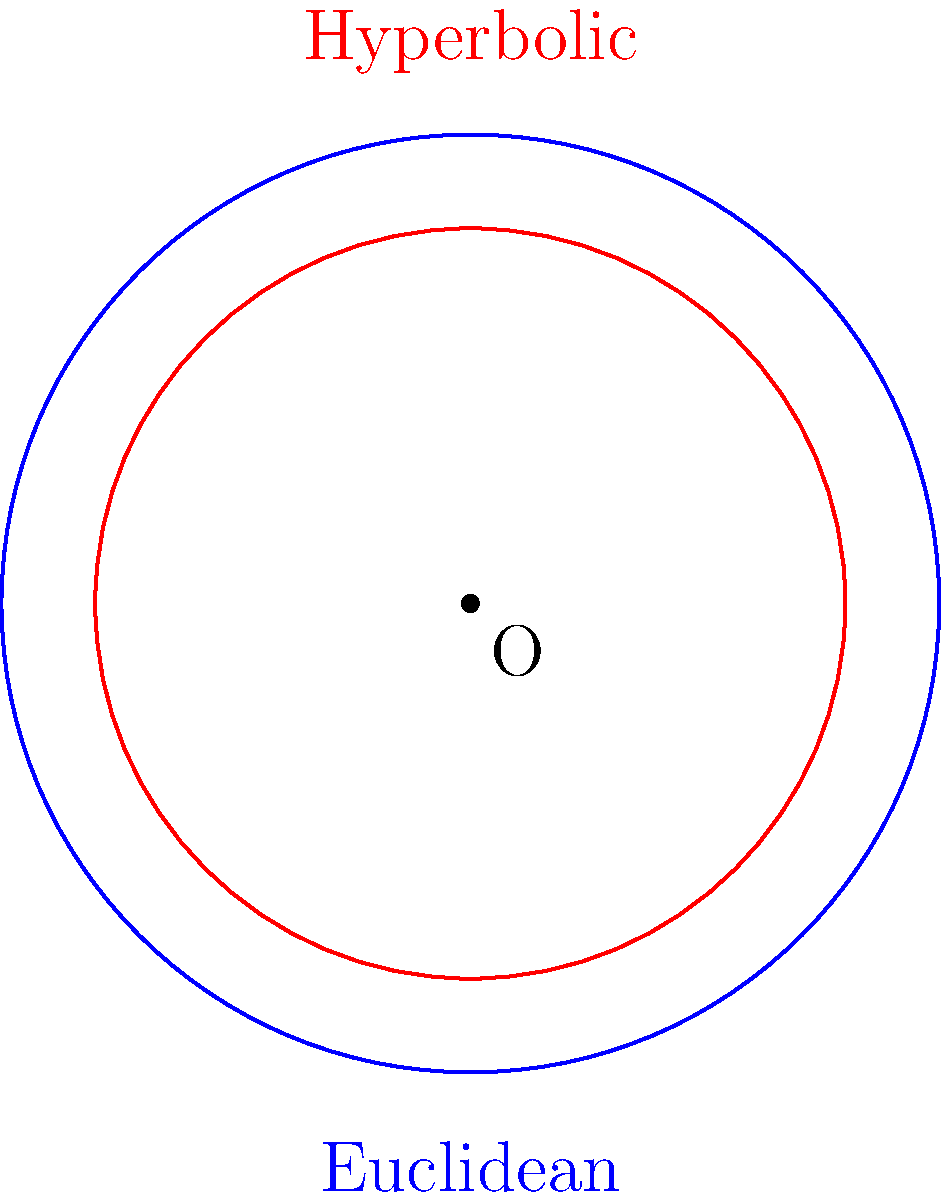In the diagram above, two circles with the same radius are shown: one in Euclidean geometry (blue) and one in hyperbolic geometry (red) using the Poincaré disk model. If the radius of both circles is 1 unit, how does the area of the hyperbolic circle compare to the area of the Euclidean circle? Let's approach this step-by-step:

1) In Euclidean geometry, the area of a circle with radius $r$ is given by:
   $$A_E = \pi r^2$$

2) For a circle with radius 1, the Euclidean area is:
   $$A_E = \pi (1)^2 = \pi$$

3) In hyperbolic geometry (using the Poincaré disk model), the area of a circle with radius $r$ is given by:
   $$A_H = 4\pi \sinh^2(\frac{r}{2})$$
   where $\sinh$ is the hyperbolic sine function.

4) For a circle with radius 1, the hyperbolic area is:
   $$A_H = 4\pi \sinh^2(\frac{1}{2})$$

5) The hyperbolic sine of 1/2 is approximately 0.5211, so:
   $$A_H \approx 4\pi (0.5211)^2 \approx 3.4249$$

6) Comparing the two areas:
   $$\frac{A_H}{A_E} \approx \frac{3.4249}{\pi} \approx 1.0899$$

This means the area of the hyperbolic circle is about 1.0899 times larger than the area of the Euclidean circle with the same radius.
Answer: The hyperbolic circle's area is approximately 8.99% larger than the Euclidean circle's area. 